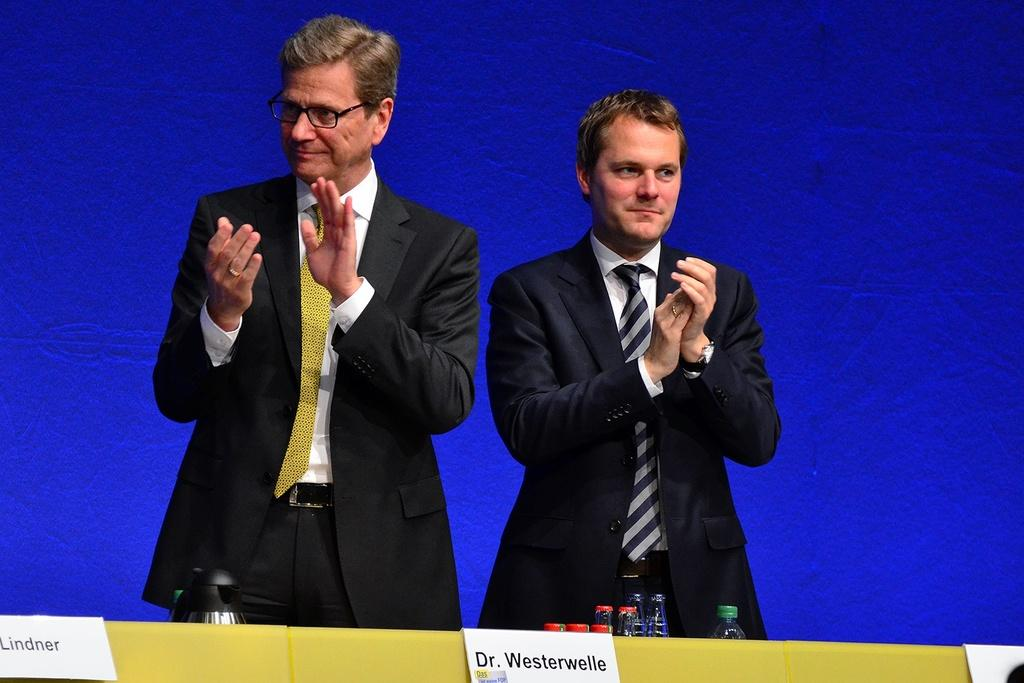How many people are in the image? There are two men standing in the image. What are the men doing in the image? The men are clapping and smiling. What can be seen at the bottom of the image? There are name boards visible at the bottom of the image. What items are related to the bottles in the image? There are lids in the image that are related to the bottles. What is the color of the background in the image? There is a blue background in the image. What type of apparel is the man on the left wearing in the image? There is no specific information about the apparel of the men in the image, so we cannot answer this question definitively. 